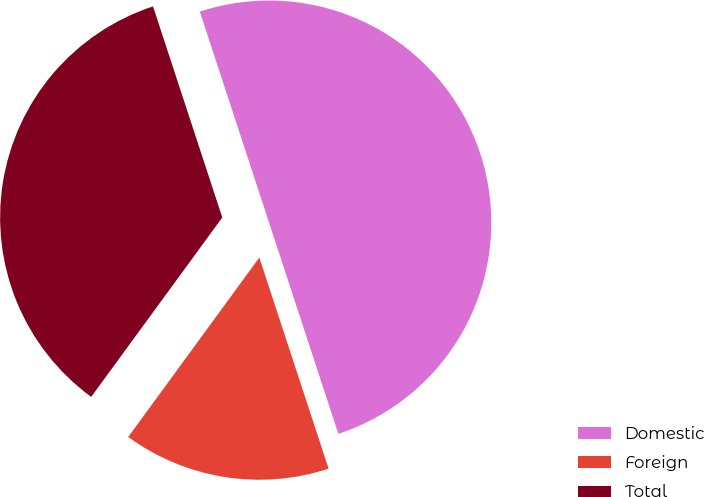Convert chart to OTSL. <chart><loc_0><loc_0><loc_500><loc_500><pie_chart><fcel>Domestic<fcel>Foreign<fcel>Total<nl><fcel>50.0%<fcel>15.09%<fcel>34.91%<nl></chart> 